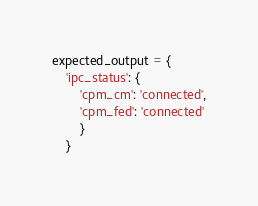Convert code to text. <code><loc_0><loc_0><loc_500><loc_500><_Python_>expected_output = {
    'ipc_status': {
	    'cpm_cm': 'connected',
		'cpm_fed': 'connected'
		}
	} </code> 